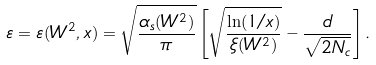Convert formula to latex. <formula><loc_0><loc_0><loc_500><loc_500>\varepsilon = \varepsilon ( W ^ { 2 } , x ) = \sqrt { \frac { \alpha _ { s } ( W ^ { 2 } ) } { \pi } } \left [ \sqrt { \frac { \ln ( 1 / x ) } { \xi ( W ^ { 2 } ) } } - \frac { d } { \sqrt { 2 N _ { c } } } \right ] .</formula> 